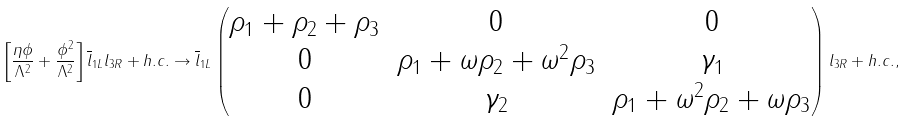Convert formula to latex. <formula><loc_0><loc_0><loc_500><loc_500>\left [ \frac { \eta \phi } { \Lambda ^ { 2 } } + \frac { \phi ^ { 2 } } { \Lambda ^ { 2 } } \right ] \overline { l } _ { 1 L } l _ { 3 R } + h . c . \to \overline { l } _ { 1 L } \begin{pmatrix} \rho _ { 1 } + \rho _ { 2 } + \rho _ { 3 } & 0 & 0 \\ 0 & \rho _ { 1 } + \omega \rho _ { 2 } + \omega ^ { 2 } \rho _ { 3 } & \gamma _ { 1 } \\ 0 & \gamma _ { 2 } & \rho _ { 1 } + \omega ^ { 2 } \rho _ { 2 } + \omega \rho _ { 3 } \end{pmatrix} l _ { 3 R } + h . c . ,</formula> 